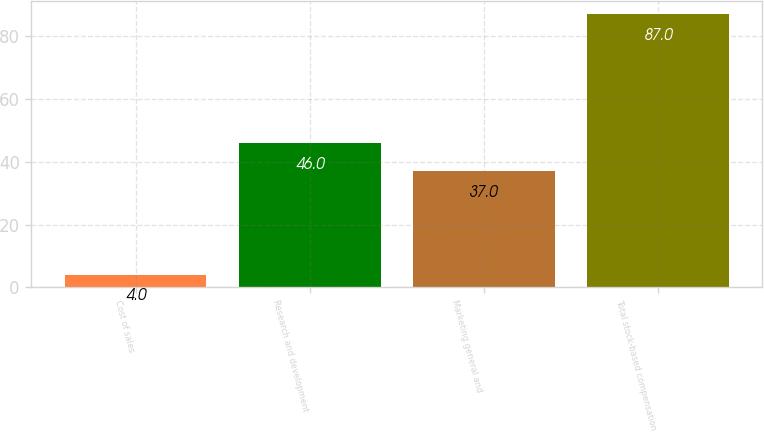<chart> <loc_0><loc_0><loc_500><loc_500><bar_chart><fcel>Cost of sales<fcel>Research and development<fcel>Marketing general and<fcel>Total stock-based compensation<nl><fcel>4<fcel>46<fcel>37<fcel>87<nl></chart> 